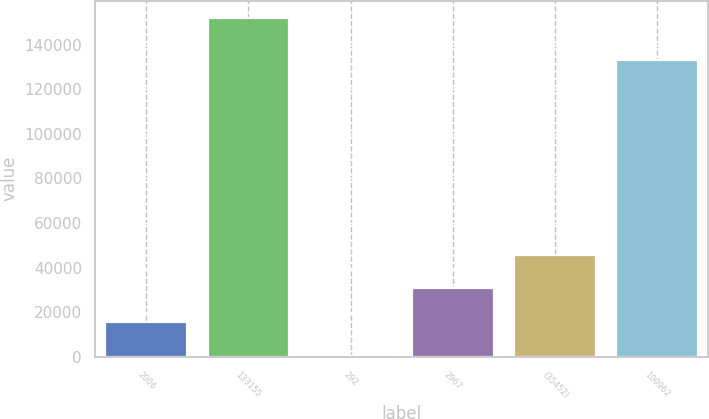Convert chart. <chart><loc_0><loc_0><loc_500><loc_500><bar_chart><fcel>2006<fcel>133155<fcel>292<fcel>2967<fcel>(35452)<fcel>100962<nl><fcel>15412.3<fcel>152179<fcel>216<fcel>30608.6<fcel>45804.9<fcel>133155<nl></chart> 